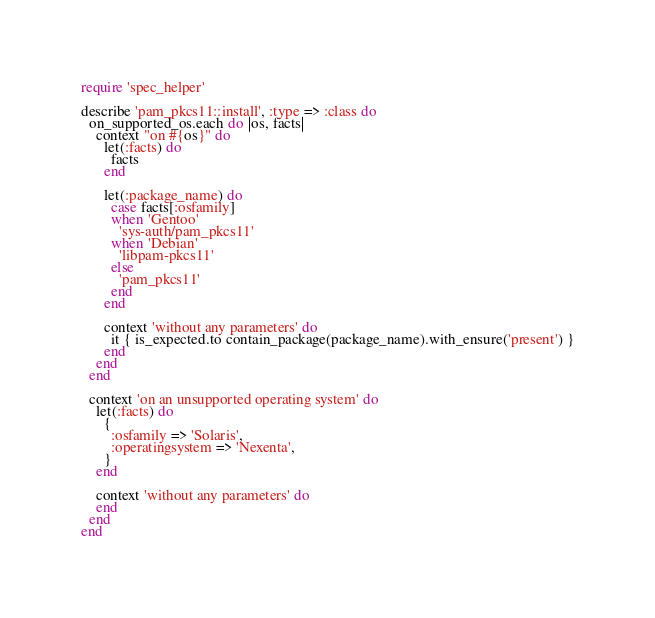Convert code to text. <code><loc_0><loc_0><loc_500><loc_500><_Ruby_>require 'spec_helper'

describe 'pam_pkcs11::install', :type => :class do
  on_supported_os.each do |os, facts|
    context "on #{os}" do
      let(:facts) do
        facts
      end

      let(:package_name) do
        case facts[:osfamily]
        when 'Gentoo'
          'sys-auth/pam_pkcs11'
        when 'Debian'
          'libpam-pkcs11'
        else
          'pam_pkcs11'
        end
      end

      context 'without any parameters' do
        it { is_expected.to contain_package(package_name).with_ensure('present') }
      end
    end
  end

  context 'on an unsupported operating system' do
    let(:facts) do
      {
        :osfamily => 'Solaris',
        :operatingsystem => 'Nexenta',
      }
    end

    context 'without any parameters' do
    end
  end
end
</code> 